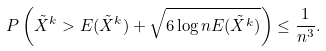Convert formula to latex. <formula><loc_0><loc_0><loc_500><loc_500>P \left ( \tilde { X } ^ { k } > E ( \tilde { X } ^ { k } ) + \sqrt { 6 \log { n } E ( \tilde { X } ^ { k } ) } \right ) \leq \frac { 1 } { n ^ { 3 } } .</formula> 